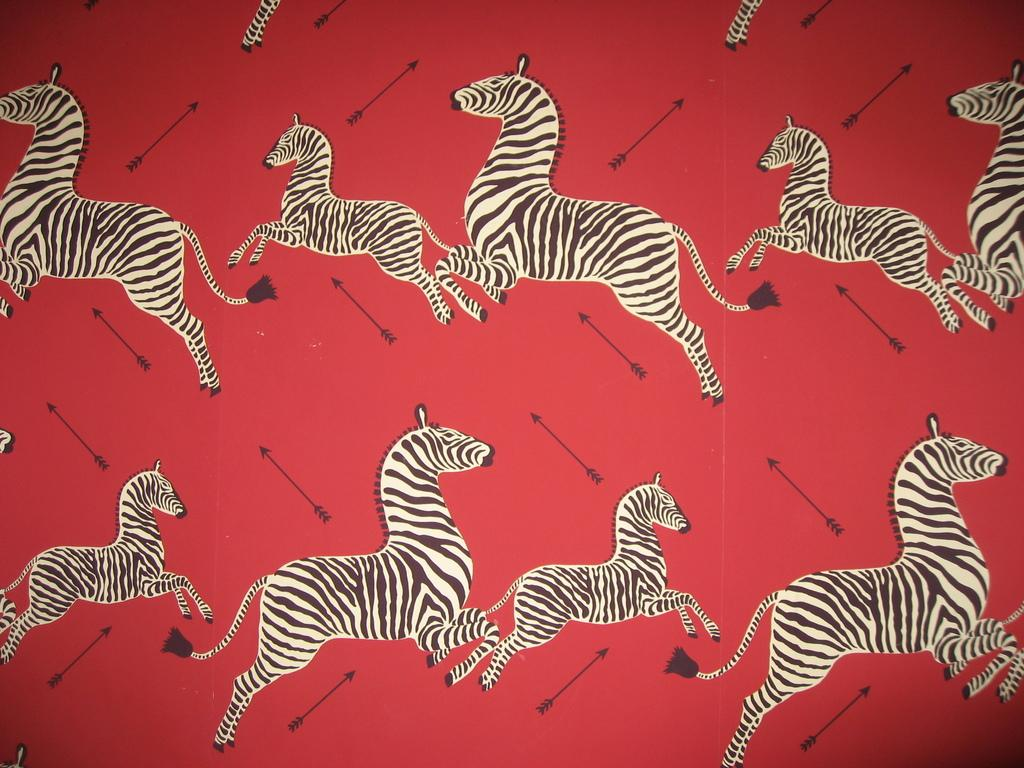What animals are present in the image? There are zebras in the image. What can be seen on the red surface in the image? There are objects on a red surface in the image. What type of story is being told by the zebras in the image? There is no story being told by the zebras in the image; they are simply animals present in the scene. 